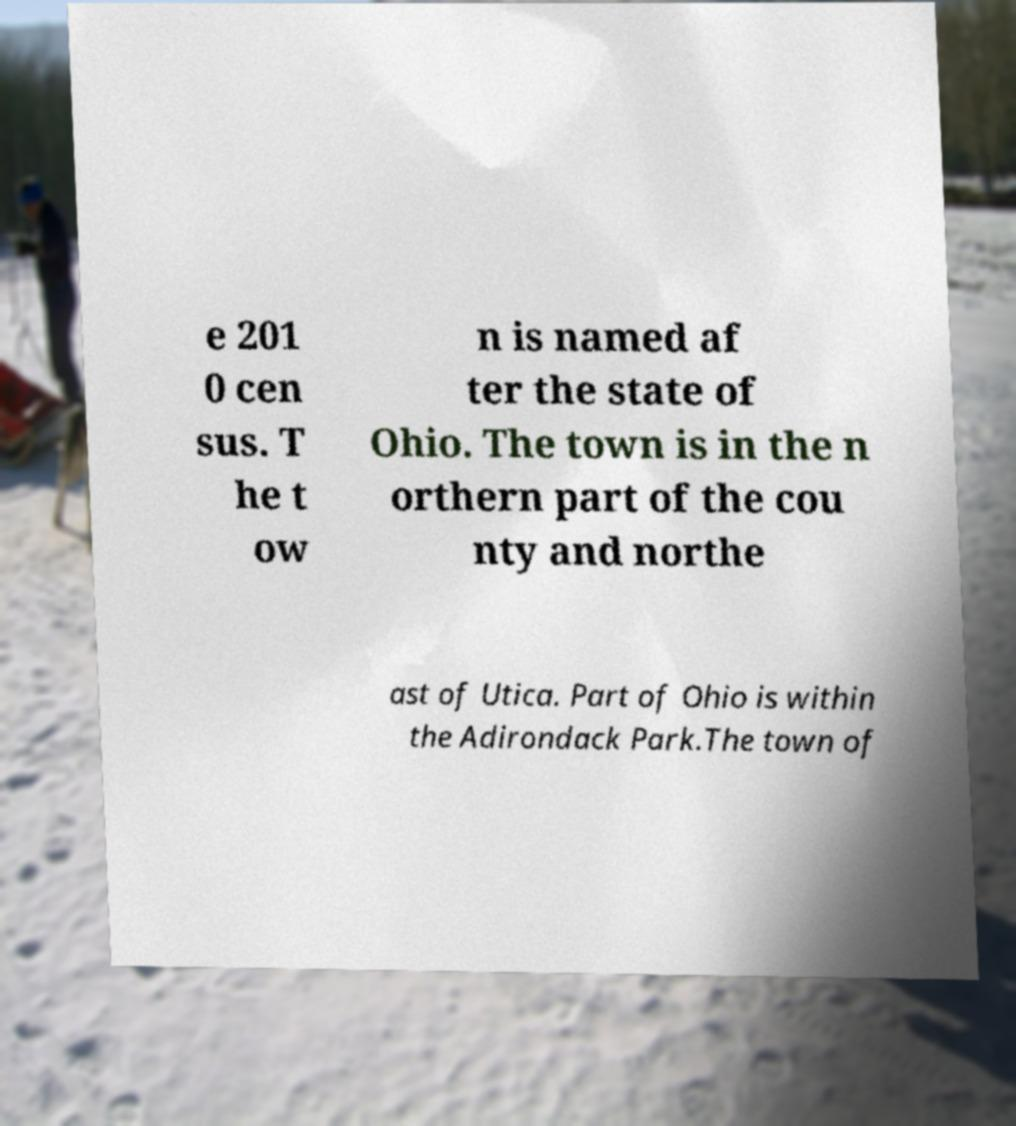What messages or text are displayed in this image? I need them in a readable, typed format. e 201 0 cen sus. T he t ow n is named af ter the state of Ohio. The town is in the n orthern part of the cou nty and northe ast of Utica. Part of Ohio is within the Adirondack Park.The town of 